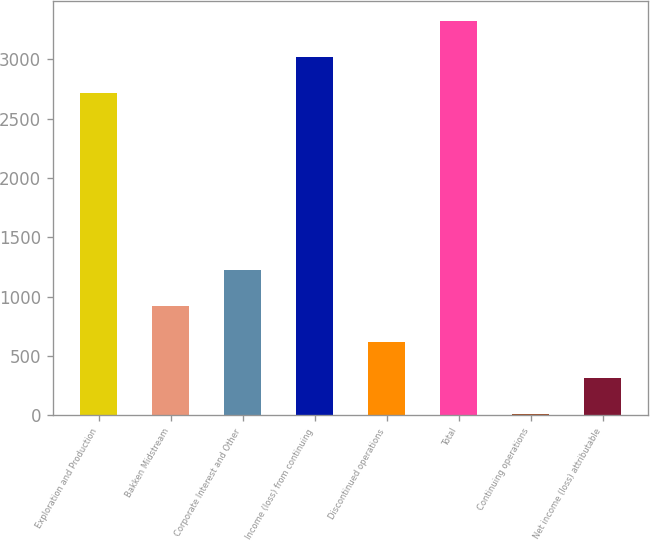<chart> <loc_0><loc_0><loc_500><loc_500><bar_chart><fcel>Exploration and Production<fcel>Bakken Midstream<fcel>Corporate Interest and Other<fcel>Income (loss) from continuing<fcel>Discontinued operations<fcel>Total<fcel>Continuing operations<fcel>Net income (loss) attributable<nl><fcel>2717<fcel>924.23<fcel>1228.77<fcel>3021.54<fcel>619.69<fcel>3326.08<fcel>10.61<fcel>315.15<nl></chart> 